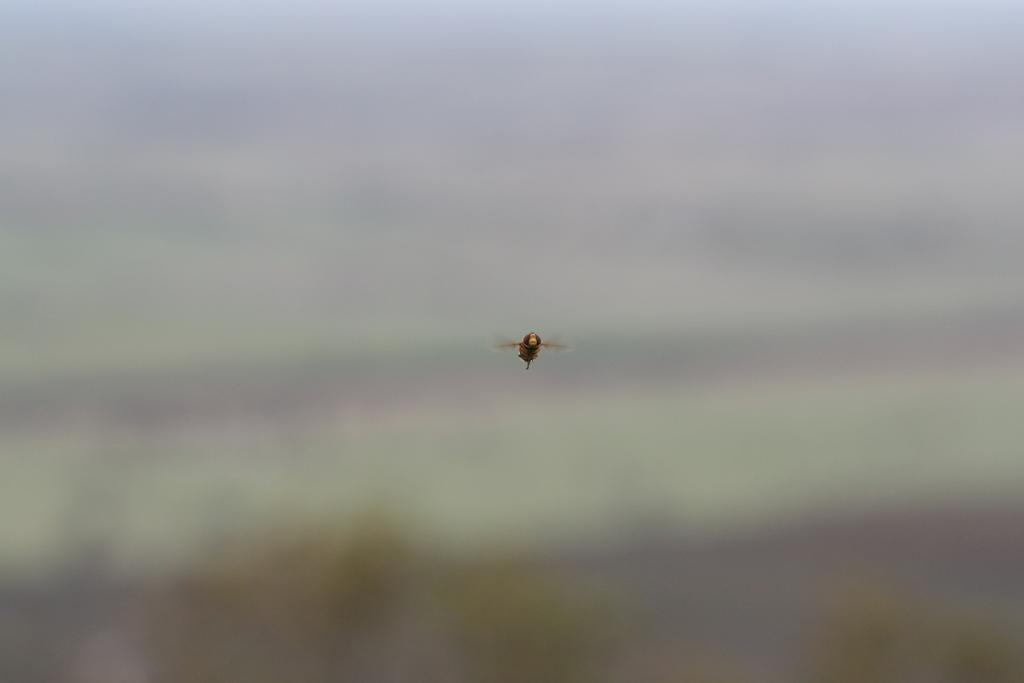What is the main subject of the image? There is a bee in the image. What is the bee doing in the image? The bee is flying in the air. Can you describe the background of the image? The background of the image is blurred. What type of fiction is the bee reading while flying in the image? There is no indication in the image that the bee is reading any fiction, as bees do not read. 